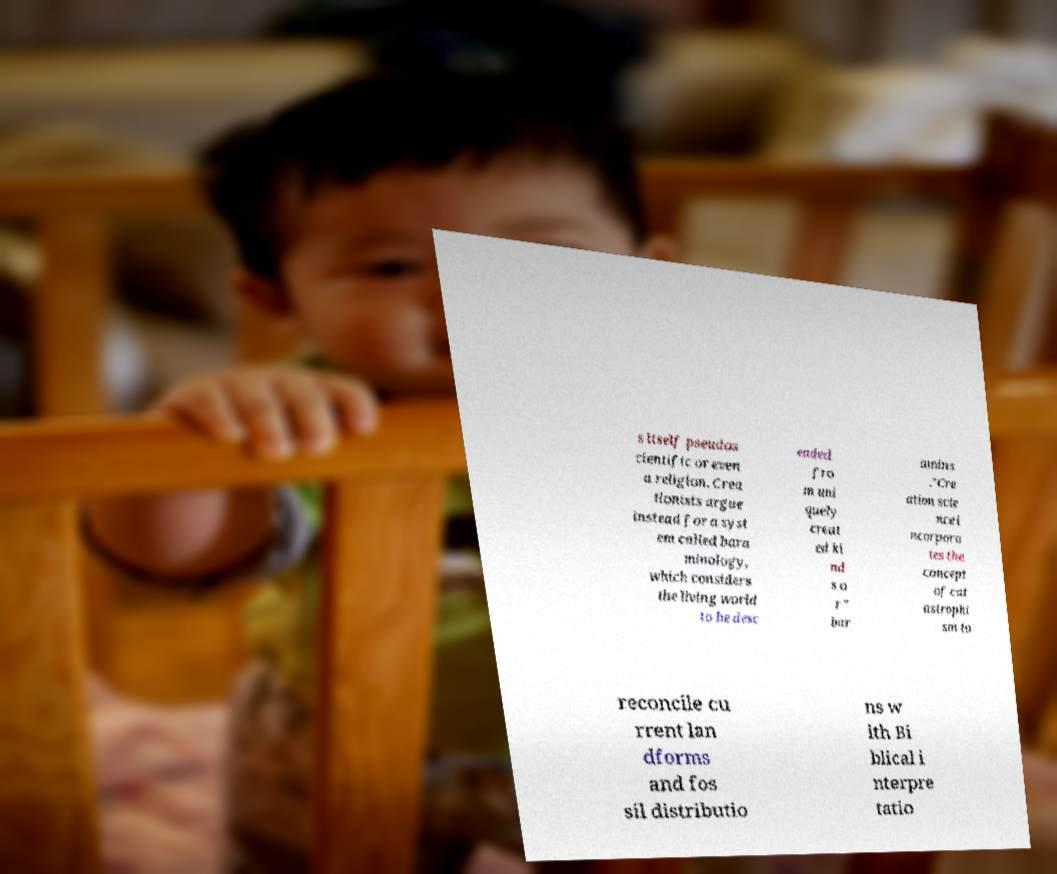Please read and relay the text visible in this image. What does it say? s itself pseudos cientific or even a religion. Crea tionists argue instead for a syst em called bara minology, which considers the living world to be desc ended fro m uni quely creat ed ki nd s o r " bar amins ."Cre ation scie nce i ncorpora tes the concept of cat astrophi sm to reconcile cu rrent lan dforms and fos sil distributio ns w ith Bi blical i nterpre tatio 